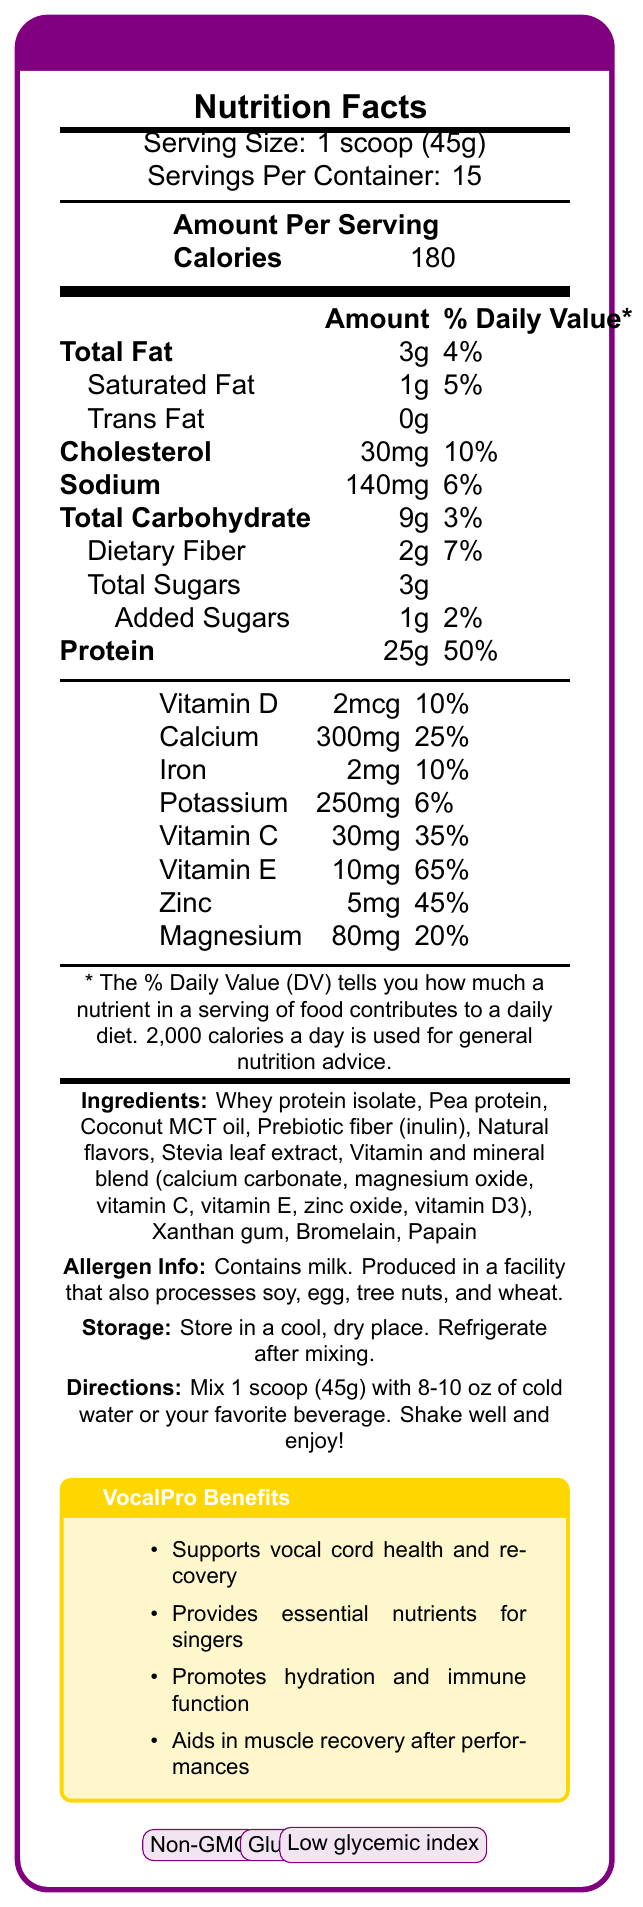what is the serving size? The serving size is clearly listed as "Serving Size: 1 scoop (45g)" in the document.
Answer: 1 scoop (45g) how many servings are in one container? The document states "Servings Per Container: 15".
Answer: 15 what is the total amount of protein per serving? The amount of protein per serving is listed as “Protein: 25g” under "Amount Per Serving".
Answer: 25g how many calories are there per serving? The document clearly states "Calories: 180" in the "Amount Per Serving" section.
Answer: 180 what percentage of the daily value of sodium does each serving contain? The percentage of daily value for sodium is listed as "Sodium: 140mg 6%" under "Amount Per Serving".
Answer: 6% which vitamin is found in the greatest quantity by daily value percentage? 
1. Vitamin D 
2. Vitamin C
3. Vitamin E
4. Zinc Vitamin E is listed with a daily value percentage of 65%, which is the highest among the vitamins and minerals listed.
Answer: 3 what is the first ingredient listed? 
A. Pea protein
B. Whey protein isolate
C. Coconut MCT oil
D. Xanthan gum The first ingredient listed is "Whey protein isolate".
Answer: B does this product contain any allergens? The section labeled “Allergen Info” states “Contains milk. Produced in a facility that also processes soy, egg, tree nuts, and wheat.”
Answer: Yes is this product gluten-free? The document lists "Gluten-free" as one of the certifications at the end.
Answer: Yes do we know the price of VocalPro Protein Shake from the document? The document does not provide any information regarding the price of the product.
Answer: Not enough information describe the main purpose of the VocalPro Protein Shake based on the document. The document highlights that this protein shake is formulated specifically for vocal health, offering various nutrients to support singers and other related benefits in the section "VocalPro Benefits".
Answer: The VocalPro Protein Shake is designed to support vocal cord health and recovery, provide essential nutrients for singers, promote hydration and immune function, and aid in muscle recovery after performances. 